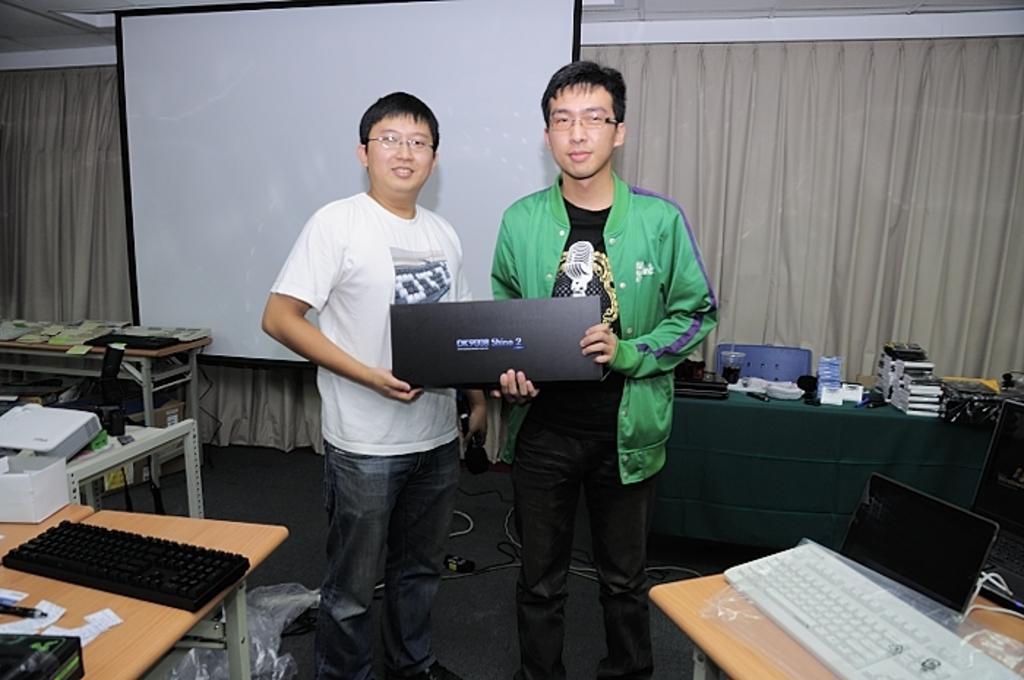Please provide a concise description of this image. In this image there are two tables on which there a keyboards and two men are standing and holding a laptop in the background thee is a table on which some objects are placed and some curtains which is in white color there is a power point projection wall. 